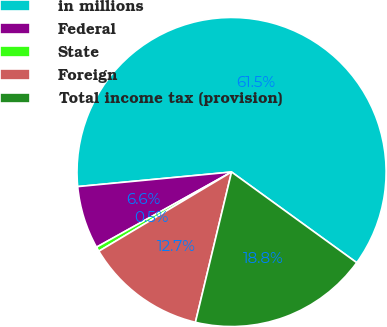Convert chart to OTSL. <chart><loc_0><loc_0><loc_500><loc_500><pie_chart><fcel>in millions<fcel>Federal<fcel>State<fcel>Foreign<fcel>Total income tax (provision)<nl><fcel>61.49%<fcel>6.58%<fcel>0.48%<fcel>12.68%<fcel>18.78%<nl></chart> 